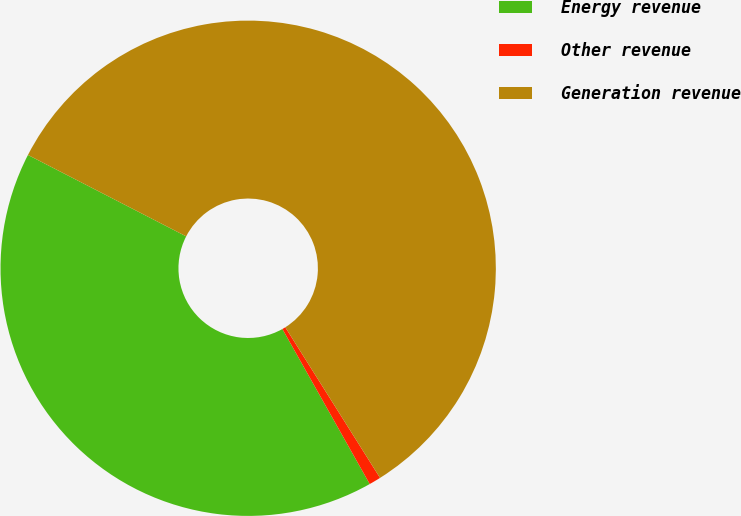Convert chart to OTSL. <chart><loc_0><loc_0><loc_500><loc_500><pie_chart><fcel>Energy revenue<fcel>Other revenue<fcel>Generation revenue<nl><fcel>40.73%<fcel>0.77%<fcel>58.5%<nl></chart> 